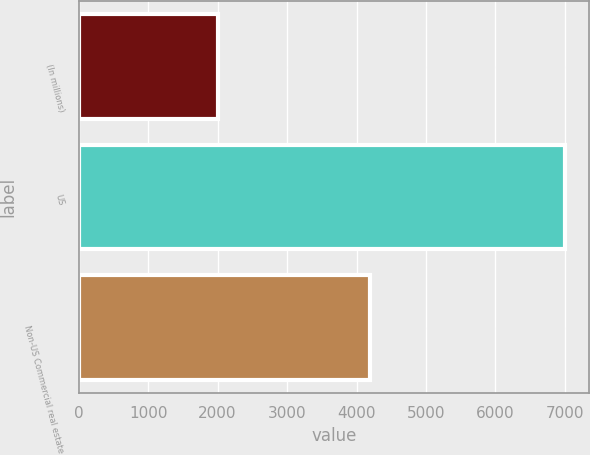Convert chart to OTSL. <chart><loc_0><loc_0><loc_500><loc_500><bar_chart><fcel>(In millions)<fcel>US<fcel>Non-US Commercial real estate<nl><fcel>2010<fcel>7001<fcel>4192<nl></chart> 